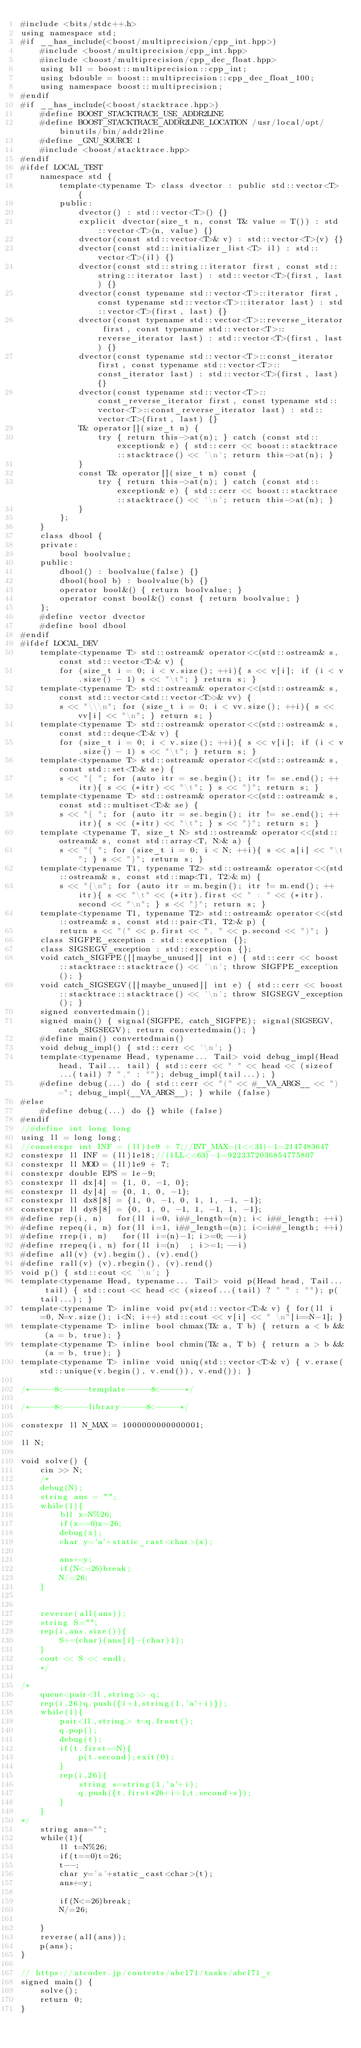<code> <loc_0><loc_0><loc_500><loc_500><_C++_>#include <bits/stdc++.h>
using namespace std;
#if __has_include(<boost/multiprecision/cpp_int.hpp>)
	#include <boost/multiprecision/cpp_int.hpp>
	#include <boost/multiprecision/cpp_dec_float.hpp>
	using bll = boost::multiprecision::cpp_int;
	using bdouble = boost::multiprecision::cpp_dec_float_100;
	using namespace boost::multiprecision;
#endif
#if __has_include(<boost/stacktrace.hpp>)
	#define BOOST_STACKTRACE_USE_ADDR2LINE
	#define BOOST_STACKTRACE_ADDR2LINE_LOCATION /usr/local/opt/binutils/bin/addr2line
	#define _GNU_SOURCE 1
	#include <boost/stacktrace.hpp>
#endif
#ifdef LOCAL_TEST
	namespace std {
		template<typename T> class dvector : public std::vector<T> {
		public:
			dvector() : std::vector<T>() {}
			explicit dvector(size_t n, const T& value = T()) : std::vector<T>(n, value) {}
			dvector(const std::vector<T>& v) : std::vector<T>(v) {}
			dvector(const std::initializer_list<T> il) : std::vector<T>(il) {}
			dvector(const std::string::iterator first, const std::string::iterator last) : std::vector<T>(first, last) {}
			dvector(const typename std::vector<T>::iterator first, const typename std::vector<T>::iterator last) : std::vector<T>(first, last) {}
			dvector(const typename std::vector<T>::reverse_iterator first, const typename std::vector<T>::reverse_iterator last) : std::vector<T>(first, last) {}
			dvector(const typename std::vector<T>::const_iterator first, const typename std::vector<T>::const_iterator last) : std::vector<T>(first, last) {}
			dvector(const typename std::vector<T>::const_reverse_iterator first, const typename std::vector<T>::const_reverse_iterator last) : std::vector<T>(first, last) {}
			T& operator[](size_t n) {
				try { return this->at(n); } catch (const std::exception& e) { std::cerr << boost::stacktrace::stacktrace() << '\n'; return this->at(n); }
			}
			const T& operator[](size_t n) const {
				try { return this->at(n); } catch (const std::exception& e) { std::cerr << boost::stacktrace::stacktrace() << '\n'; return this->at(n); }
			}
		};
	}
	class dbool {
	private:
		bool boolvalue;
	public:
		dbool() : boolvalue(false) {}
		dbool(bool b) : boolvalue(b) {}
		operator bool&() { return boolvalue; }
		operator const bool&() const { return boolvalue; }
	};
	#define vector dvector
	#define bool dbool
#endif
#ifdef LOCAL_DEV
	template<typename T> std::ostream& operator<<(std::ostream& s, const std::vector<T>& v) {
		for (size_t i = 0; i < v.size(); ++i){ s << v[i]; if (i < v.size() - 1) s << "\t"; } return s; }
	template<typename T> std::ostream& operator<<(std::ostream& s, const std::vector<std::vector<T>>& vv) {
		s << "\\\n"; for (size_t i = 0; i < vv.size(); ++i){ s << vv[i] << "\n"; } return s; }
	template<typename T> std::ostream& operator<<(std::ostream& s, const std::deque<T>& v) {
		for (size_t i = 0; i < v.size(); ++i){ s << v[i]; if (i < v.size() - 1) s << "\t"; } return s; }
	template<typename T> std::ostream& operator<<(std::ostream& s, const std::set<T>& se) {
		s << "{ "; for (auto itr = se.begin(); itr != se.end(); ++itr){ s << (*itr) << "\t"; } s << "}"; return s; }
	template<typename T> std::ostream& operator<<(std::ostream& s, const std::multiset<T>& se) {
		s << "{ "; for (auto itr = se.begin(); itr != se.end(); ++itr){ s << (*itr) << "\t"; } s << "}"; return s; }
	template <typename T, size_t N> std::ostream& operator<<(std::ostream& s, const std::array<T, N>& a) {
		s << "{ "; for (size_t i = 0; i < N; ++i){ s << a[i] << "\t"; } s << "}"; return s; }
	template<typename T1, typename T2> std::ostream& operator<<(std::ostream& s, const std::map<T1, T2>& m) {
		s << "{\n"; for (auto itr = m.begin(); itr != m.end(); ++itr){ s << "\t" << (*itr).first << " : " << (*itr).second << "\n"; } s << "}"; return s; }
	template<typename T1, typename T2> std::ostream& operator<<(std::ostream& s, const std::pair<T1, T2>& p) {
		return s << "(" << p.first << ", " << p.second << ")"; }
	class SIGFPE_exception : std::exception {};
	class SIGSEGV_exception : std::exception {};
	void catch_SIGFPE([[maybe_unused]] int e) { std::cerr << boost::stacktrace::stacktrace() << '\n'; throw SIGFPE_exception(); }
	void catch_SIGSEGV([[maybe_unused]] int e) { std::cerr << boost::stacktrace::stacktrace() << '\n'; throw SIGSEGV_exception(); }
	signed convertedmain();
	signed main() { signal(SIGFPE, catch_SIGFPE); signal(SIGSEGV, catch_SIGSEGV); return convertedmain(); }
	#define main() convertedmain()
	void debug_impl() { std::cerr << '\n'; }
	template<typename Head, typename... Tail> void debug_impl(Head head, Tail... tail) { std::cerr << " " << head << (sizeof...(tail) ? "," : ""); debug_impl(tail...); }
	#define debug(...) do { std::cerr << "(" << #__VA_ARGS__ << ") ="; debug_impl(__VA_ARGS__); } while (false)
#else
	#define debug(...) do {} while (false)
#endif
//#define int long long
using ll = long long;
//constexpr int INF = (ll)1e9 + 7;//INT_MAX=(1<<31)-1=2147483647
constexpr ll INF = (ll)1e18;//(1LL<<63)-1=9223372036854775807
constexpr ll MOD = (ll)1e9 + 7;
constexpr double EPS = 1e-9;
constexpr ll dx[4] = {1, 0, -1, 0};
constexpr ll dy[4] = {0, 1, 0, -1};
constexpr ll dx8[8] = {1, 0, -1, 0, 1, 1, -1, -1};
constexpr ll dy8[8] = {0, 1, 0, -1, 1, -1, 1, -1};
#define rep(i, n)   for(ll i=0, i##_length=(n); i< i##_length; ++i)
#define repeq(i, n) for(ll i=1, i##_length=(n); i<=i##_length; ++i)
#define rrep(i, n)   for(ll i=(n)-1; i>=0; --i)
#define rrepeq(i, n) for(ll i=(n)  ; i>=1; --i)
#define all(v) (v).begin(), (v).end()
#define rall(v) (v).rbegin(), (v).rend()
void p() { std::cout << '\n'; }
template<typename Head, typename... Tail> void p(Head head, Tail... tail) { std::cout << head << (sizeof...(tail) ? " " : ""); p(tail...); }
template<typename T> inline void pv(std::vector<T>& v) { for(ll i=0, N=v.size(); i<N; i++) std::cout << v[i] << " \n"[i==N-1]; }
template<typename T> inline bool chmax(T& a, T b) { return a < b && (a = b, true); }
template<typename T> inline bool chmin(T& a, T b) { return a > b && (a = b, true); }
template<typename T> inline void uniq(std::vector<T>& v) { v.erase(std::unique(v.begin(), v.end()), v.end()); }

/*-----8<-----template-----8<-----*/

/*-----8<-----library-----8<-----*/

constexpr ll N_MAX = 1000000000000001;

ll N;

void solve() {
	cin >> N;
	/*
	debug(N);
	string ans = "";
	while(1){
		bll x=N%26;
		if(x==0)x=26;
		debug(x);
		char y='a'+static_cast<char>(x);

		ans+=y;
		if(N<=26)break;
		N/=26;
	}
	

	reverse(all(ans));
	string S="";
	rep(i,ans.size()){
		S+=(char)(ans[i]-(char)1);
	}
	cout << S << endl;
	*/

/*
	queue<pair<ll,string>> q;
	rep(i,26)q.push({i+1,string(1,'a'+i)});
	while(1){
		pair<ll,string> t=q.front();
		q.pop();
		debug(t);
		if(t.first==N){
			p(t.second);exit(0);
		}
		rep(i,26){
			string s=string(1,'a'+i);
			q.push({t.first*26+i+1,t.second+s});
		}
	}
*/
	string ans="";
	while(1){
		ll t=N%26;
		if(t==0)t=26;
		t--;
		char y='a'+static_cast<char>(t);
		ans+=y;

		if(N<=26)break;
		N/=26;

	}
	reverse(all(ans));
	p(ans);
}

// https://atcoder.jp/contests/abc171/tasks/abc171_c
signed main() {
	solve();
	return 0;
}
</code> 